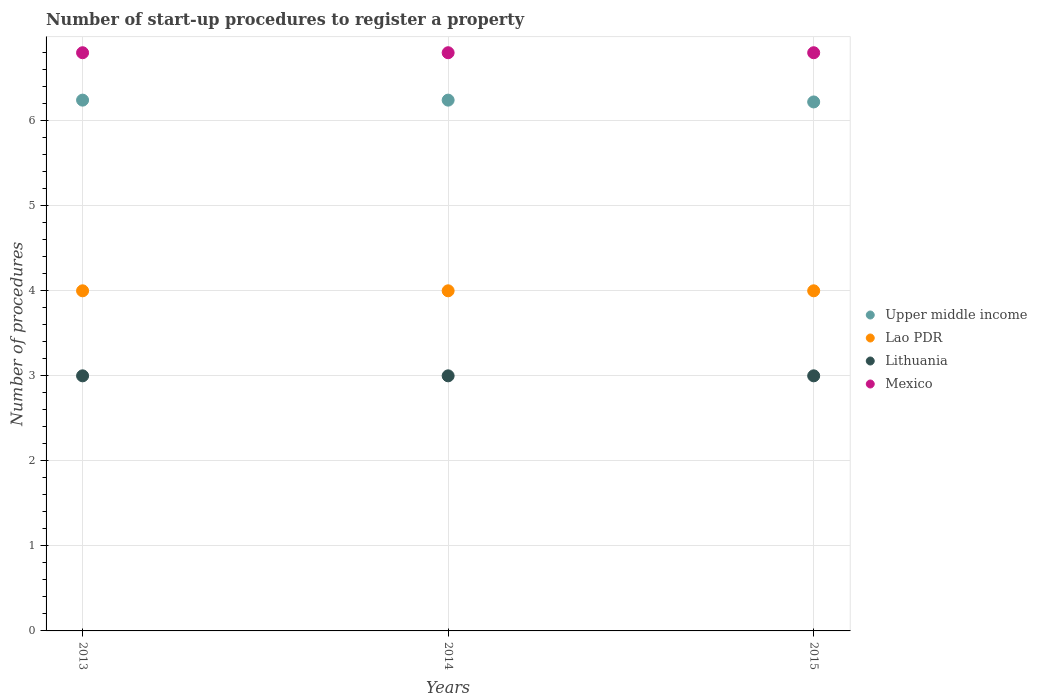How many different coloured dotlines are there?
Ensure brevity in your answer.  4. Is the number of dotlines equal to the number of legend labels?
Offer a terse response. Yes. What is the number of procedures required to register a property in Upper middle income in 2015?
Your answer should be compact. 6.22. Across all years, what is the maximum number of procedures required to register a property in Upper middle income?
Offer a very short reply. 6.24. Across all years, what is the minimum number of procedures required to register a property in Lao PDR?
Offer a very short reply. 4. In which year was the number of procedures required to register a property in Mexico maximum?
Your answer should be compact. 2013. In which year was the number of procedures required to register a property in Lao PDR minimum?
Provide a short and direct response. 2013. What is the total number of procedures required to register a property in Mexico in the graph?
Give a very brief answer. 20.4. What is the difference between the number of procedures required to register a property in Lao PDR in 2015 and the number of procedures required to register a property in Upper middle income in 2013?
Your response must be concise. -2.24. What is the average number of procedures required to register a property in Lao PDR per year?
Provide a short and direct response. 4. In the year 2013, what is the difference between the number of procedures required to register a property in Upper middle income and number of procedures required to register a property in Mexico?
Ensure brevity in your answer.  -0.56. What is the ratio of the number of procedures required to register a property in Lao PDR in 2013 to that in 2014?
Keep it short and to the point. 1. Is the number of procedures required to register a property in Mexico in 2013 less than that in 2015?
Your answer should be very brief. No. What is the difference between the highest and the second highest number of procedures required to register a property in Mexico?
Offer a very short reply. 0. What is the difference between the highest and the lowest number of procedures required to register a property in Upper middle income?
Your response must be concise. 0.02. Is the sum of the number of procedures required to register a property in Lithuania in 2013 and 2014 greater than the maximum number of procedures required to register a property in Mexico across all years?
Give a very brief answer. No. Is it the case that in every year, the sum of the number of procedures required to register a property in Lithuania and number of procedures required to register a property in Upper middle income  is greater than the number of procedures required to register a property in Lao PDR?
Make the answer very short. Yes. Does the number of procedures required to register a property in Lithuania monotonically increase over the years?
Give a very brief answer. No. Is the number of procedures required to register a property in Lithuania strictly less than the number of procedures required to register a property in Lao PDR over the years?
Offer a very short reply. Yes. Does the graph contain any zero values?
Your response must be concise. No. Does the graph contain grids?
Offer a very short reply. Yes. Where does the legend appear in the graph?
Make the answer very short. Center right. How many legend labels are there?
Your answer should be compact. 4. How are the legend labels stacked?
Offer a very short reply. Vertical. What is the title of the graph?
Provide a succinct answer. Number of start-up procedures to register a property. What is the label or title of the X-axis?
Your answer should be compact. Years. What is the label or title of the Y-axis?
Offer a very short reply. Number of procedures. What is the Number of procedures in Upper middle income in 2013?
Offer a very short reply. 6.24. What is the Number of procedures in Lithuania in 2013?
Offer a terse response. 3. What is the Number of procedures in Mexico in 2013?
Provide a short and direct response. 6.8. What is the Number of procedures in Upper middle income in 2014?
Your answer should be compact. 6.24. What is the Number of procedures of Lao PDR in 2014?
Keep it short and to the point. 4. What is the Number of procedures of Lithuania in 2014?
Offer a terse response. 3. What is the Number of procedures in Mexico in 2014?
Provide a short and direct response. 6.8. What is the Number of procedures in Upper middle income in 2015?
Provide a short and direct response. 6.22. What is the Number of procedures in Lao PDR in 2015?
Offer a very short reply. 4. What is the Number of procedures of Lithuania in 2015?
Give a very brief answer. 3. What is the Number of procedures in Mexico in 2015?
Ensure brevity in your answer.  6.8. Across all years, what is the maximum Number of procedures of Upper middle income?
Your answer should be compact. 6.24. Across all years, what is the maximum Number of procedures of Lithuania?
Your answer should be compact. 3. Across all years, what is the minimum Number of procedures of Upper middle income?
Provide a short and direct response. 6.22. Across all years, what is the minimum Number of procedures in Lao PDR?
Your answer should be compact. 4. Across all years, what is the minimum Number of procedures in Lithuania?
Your answer should be compact. 3. Across all years, what is the minimum Number of procedures of Mexico?
Make the answer very short. 6.8. What is the total Number of procedures in Upper middle income in the graph?
Offer a terse response. 18.71. What is the total Number of procedures in Mexico in the graph?
Offer a terse response. 20.4. What is the difference between the Number of procedures of Upper middle income in 2013 and that in 2014?
Provide a succinct answer. 0. What is the difference between the Number of procedures in Upper middle income in 2013 and that in 2015?
Your response must be concise. 0.02. What is the difference between the Number of procedures of Lao PDR in 2013 and that in 2015?
Keep it short and to the point. 0. What is the difference between the Number of procedures in Mexico in 2013 and that in 2015?
Keep it short and to the point. 0. What is the difference between the Number of procedures in Upper middle income in 2014 and that in 2015?
Make the answer very short. 0.02. What is the difference between the Number of procedures of Mexico in 2014 and that in 2015?
Make the answer very short. 0. What is the difference between the Number of procedures in Upper middle income in 2013 and the Number of procedures in Lao PDR in 2014?
Your response must be concise. 2.24. What is the difference between the Number of procedures of Upper middle income in 2013 and the Number of procedures of Lithuania in 2014?
Make the answer very short. 3.24. What is the difference between the Number of procedures of Upper middle income in 2013 and the Number of procedures of Mexico in 2014?
Your answer should be very brief. -0.56. What is the difference between the Number of procedures in Upper middle income in 2013 and the Number of procedures in Lao PDR in 2015?
Your answer should be very brief. 2.24. What is the difference between the Number of procedures in Upper middle income in 2013 and the Number of procedures in Lithuania in 2015?
Provide a short and direct response. 3.24. What is the difference between the Number of procedures in Upper middle income in 2013 and the Number of procedures in Mexico in 2015?
Provide a succinct answer. -0.56. What is the difference between the Number of procedures in Lithuania in 2013 and the Number of procedures in Mexico in 2015?
Give a very brief answer. -3.8. What is the difference between the Number of procedures in Upper middle income in 2014 and the Number of procedures in Lao PDR in 2015?
Your answer should be compact. 2.24. What is the difference between the Number of procedures of Upper middle income in 2014 and the Number of procedures of Lithuania in 2015?
Ensure brevity in your answer.  3.24. What is the difference between the Number of procedures of Upper middle income in 2014 and the Number of procedures of Mexico in 2015?
Offer a terse response. -0.56. What is the difference between the Number of procedures of Lao PDR in 2014 and the Number of procedures of Lithuania in 2015?
Offer a very short reply. 1. What is the difference between the Number of procedures in Lithuania in 2014 and the Number of procedures in Mexico in 2015?
Provide a succinct answer. -3.8. What is the average Number of procedures in Upper middle income per year?
Your answer should be very brief. 6.24. What is the average Number of procedures in Lao PDR per year?
Make the answer very short. 4. In the year 2013, what is the difference between the Number of procedures of Upper middle income and Number of procedures of Lao PDR?
Offer a very short reply. 2.24. In the year 2013, what is the difference between the Number of procedures of Upper middle income and Number of procedures of Lithuania?
Ensure brevity in your answer.  3.24. In the year 2013, what is the difference between the Number of procedures in Upper middle income and Number of procedures in Mexico?
Your answer should be compact. -0.56. In the year 2013, what is the difference between the Number of procedures in Lao PDR and Number of procedures in Lithuania?
Provide a short and direct response. 1. In the year 2014, what is the difference between the Number of procedures of Upper middle income and Number of procedures of Lao PDR?
Provide a short and direct response. 2.24. In the year 2014, what is the difference between the Number of procedures of Upper middle income and Number of procedures of Lithuania?
Keep it short and to the point. 3.24. In the year 2014, what is the difference between the Number of procedures of Upper middle income and Number of procedures of Mexico?
Provide a succinct answer. -0.56. In the year 2014, what is the difference between the Number of procedures in Lao PDR and Number of procedures in Lithuania?
Offer a terse response. 1. In the year 2015, what is the difference between the Number of procedures of Upper middle income and Number of procedures of Lao PDR?
Provide a succinct answer. 2.22. In the year 2015, what is the difference between the Number of procedures in Upper middle income and Number of procedures in Lithuania?
Provide a short and direct response. 3.22. In the year 2015, what is the difference between the Number of procedures in Upper middle income and Number of procedures in Mexico?
Keep it short and to the point. -0.58. In the year 2015, what is the difference between the Number of procedures of Lao PDR and Number of procedures of Mexico?
Provide a short and direct response. -2.8. In the year 2015, what is the difference between the Number of procedures of Lithuania and Number of procedures of Mexico?
Provide a succinct answer. -3.8. What is the ratio of the Number of procedures in Upper middle income in 2013 to that in 2014?
Make the answer very short. 1. What is the ratio of the Number of procedures of Lao PDR in 2013 to that in 2014?
Keep it short and to the point. 1. What is the ratio of the Number of procedures of Lithuania in 2013 to that in 2014?
Offer a terse response. 1. What is the ratio of the Number of procedures of Lao PDR in 2013 to that in 2015?
Give a very brief answer. 1. What is the ratio of the Number of procedures of Mexico in 2014 to that in 2015?
Ensure brevity in your answer.  1. What is the difference between the highest and the second highest Number of procedures in Lithuania?
Offer a very short reply. 0. What is the difference between the highest and the second highest Number of procedures of Mexico?
Ensure brevity in your answer.  0. What is the difference between the highest and the lowest Number of procedures of Upper middle income?
Your answer should be very brief. 0.02. What is the difference between the highest and the lowest Number of procedures in Lithuania?
Your answer should be very brief. 0. 